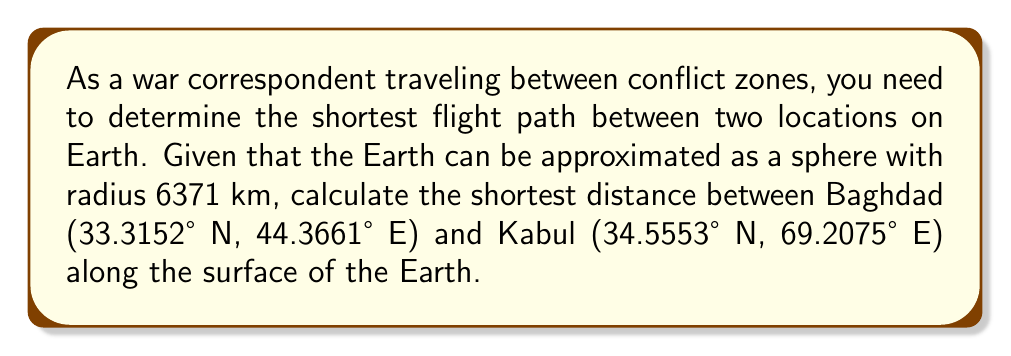Provide a solution to this math problem. To solve this problem, we'll use the great circle distance formula, which gives the shortest path between two points on a sphere. The steps are as follows:

1. Convert the latitudes and longitudes from degrees to radians:
   $$\phi_1 = 33.3152° \times \frac{\pi}{180} = 0.5815 \text{ rad}$$
   $$\lambda_1 = 44.3661° \times \frac{\pi}{180} = 0.7744 \text{ rad}$$
   $$\phi_2 = 34.5553° \times \frac{\pi}{180} = 0.6031 \text{ rad}$$
   $$\lambda_2 = 69.2075° \times \frac{\pi}{180} = 1.2080 \text{ rad}$$

2. Calculate the central angle $\Delta\sigma$ using the Haversine formula:
   $$\Delta\sigma = 2 \arcsin\left(\sqrt{\sin^2\left(\frac{\phi_2 - \phi_1}{2}\right) + \cos\phi_1 \cos\phi_2 \sin^2\left(\frac{\lambda_2 - \lambda_1}{2}\right)}\right)$$

3. Substitute the values:
   $$\Delta\sigma = 2 \arcsin\left(\sqrt{\sin^2\left(\frac{0.6031 - 0.5815}{2}\right) + \cos(0.5815) \cos(0.6031) \sin^2\left(\frac{1.2080 - 0.7744}{2}\right)}\right)$$

4. Calculate the result:
   $$\Delta\sigma = 0.4169 \text{ rad}$$

5. Multiply by the Earth's radius to get the distance:
   $$d = R \cdot \Delta\sigma = 6371 \text{ km} \times 0.4169 \text{ rad} = 2656 \text{ km}$$

[asy]
import geometry;

size(200);
pair O=(0,0);
real R=5;
draw(circle(O,R));

real phi1=33.3152*pi/180, lambda1=44.3661*pi/180;
real phi2=34.5553*pi/180, lambda2=69.2075*pi/180;

pair P1=(R*cos(phi1)*cos(lambda1), R*sin(phi1));
pair P2=(R*cos(phi2)*cos(lambda2), R*sin(phi2));

draw(O--P1,dashed);
draw(O--P2,dashed);
draw(P1--P2,red);

label("Baghdad",P1,SW);
label("Kabul",P2,SE);
label("Earth",O,S);
[/asy]
Answer: 2656 km 